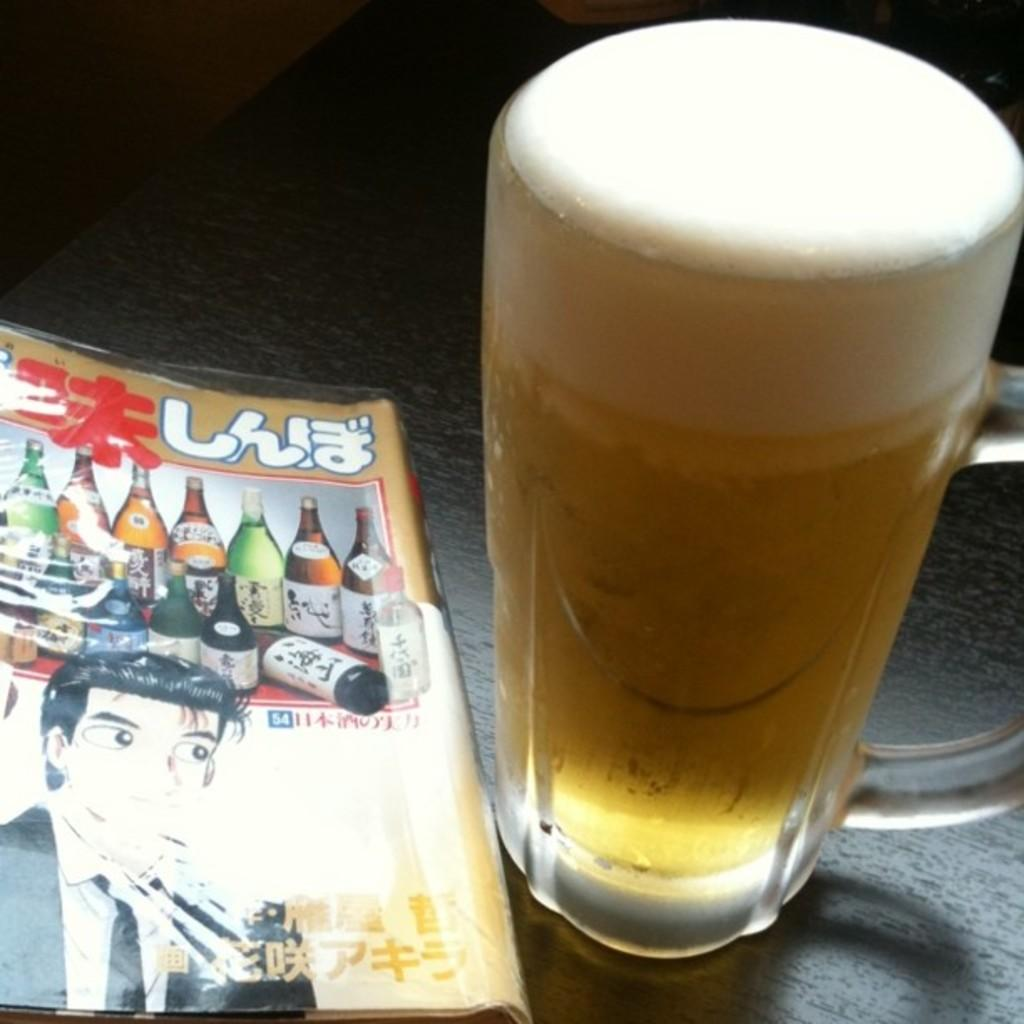What piece of furniture is in the image? There is a table in the image. What is on top of the table? There is a book and a glass with a drink in it on the table. What is on top of the book? There are bottles visible on the book. Who is present in the image? A person is present in the image. How many feet of land can be seen in the image? There is no land visible in the image; it features a table with various objects on it and a person. 